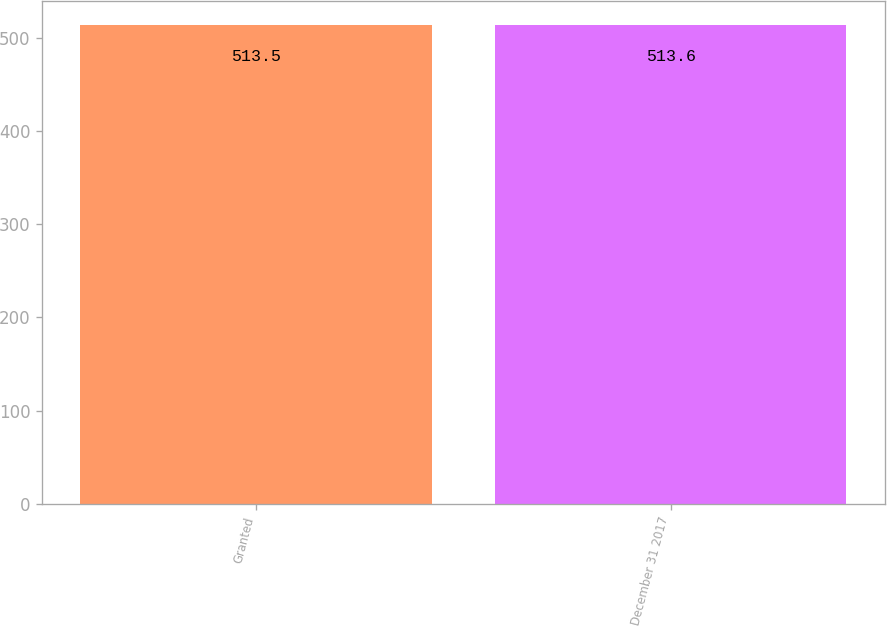Convert chart to OTSL. <chart><loc_0><loc_0><loc_500><loc_500><bar_chart><fcel>Granted<fcel>December 31 2017<nl><fcel>513.5<fcel>513.6<nl></chart> 